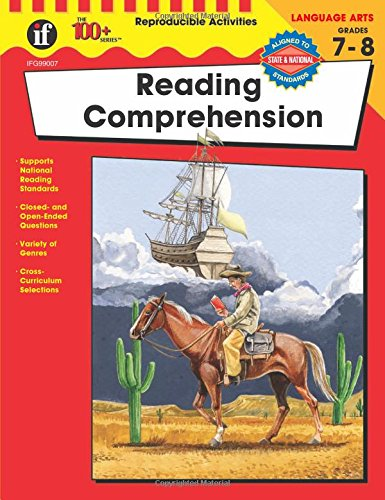What type of book is this? This is an educational book specifically tailored for teens and young adults, focusing on enhancing reading comprehension skills through varied exercises and curriculum-relevant content. 